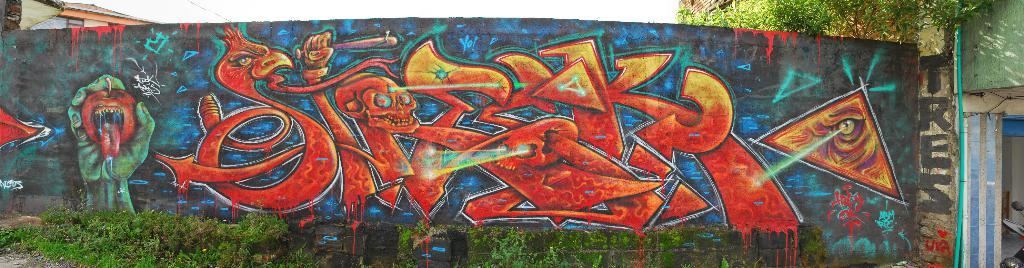What is depicted on the wall in the image? There are paintings on a wall in the image. What is located in front of the wall? There are small plants in front of the wall. What can be seen behind the plants? There is a tree behind the plants. What type of dock can be seen near the tree in the image? There is no dock present in the image; it features paintings on a wall, small plants, and a tree. How does the growth of the plants affect the art on the wall? The provided facts do not mention any growth of the plants or any interaction between the plants and the art on the wall. 